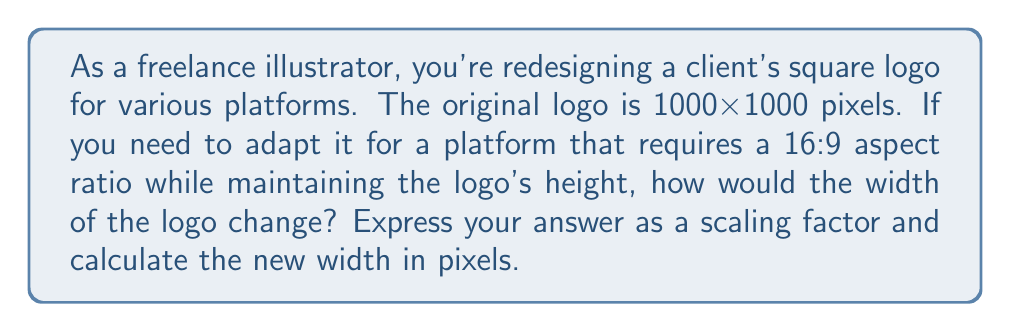Provide a solution to this math problem. Let's approach this step-by-step:

1) The original logo is square, so its aspect ratio is 1:1.

2) The new aspect ratio is 16:9. This means for every 9 units of height, there should be 16 units of width.

3) We're maintaining the logo's height, so we need to focus on how the width changes.

4) To find the scaling factor for the width, we can set up a proportion:

   $$\frac{\text{new width}}{\text{new height}} = \frac{16}{9}$$

5) Since the height remains the same, we can substitute the original dimensions:

   $$\frac{\text{new width}}{1000} = \frac{16}{9}$$

6) Cross multiply:

   $$9 \cdot \text{new width} = 16 \cdot 1000$$

7) Solve for the new width:

   $$\text{new width} = \frac{16 \cdot 1000}{9} = \frac{16000}{9} \approx 1777.78$$

8) To find the scaling factor, divide the new width by the original width:

   $$\text{scaling factor} = \frac{\text{new width}}{\text{original width}} = \frac{1777.78}{1000} \approx 1.78$$

Therefore, the width needs to be scaled by a factor of approximately 1.78, and the new width would be about 1778 pixels.
Answer: The width scaling factor is $\frac{16}{9} \approx 1.78$, and the new width is approximately 1778 pixels. 